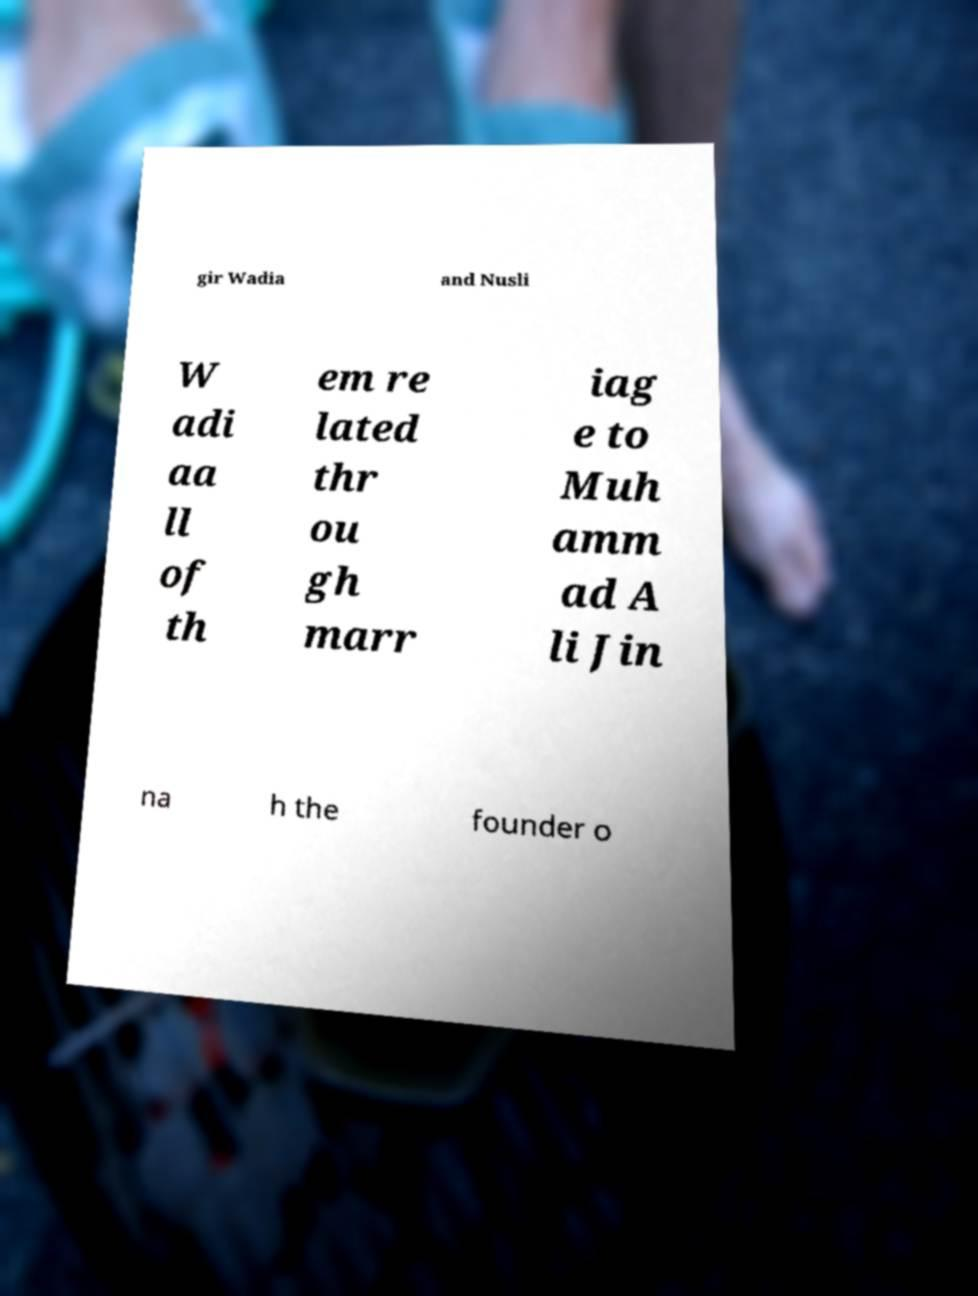What messages or text are displayed in this image? I need them in a readable, typed format. gir Wadia and Nusli W adi aa ll of th em re lated thr ou gh marr iag e to Muh amm ad A li Jin na h the founder o 